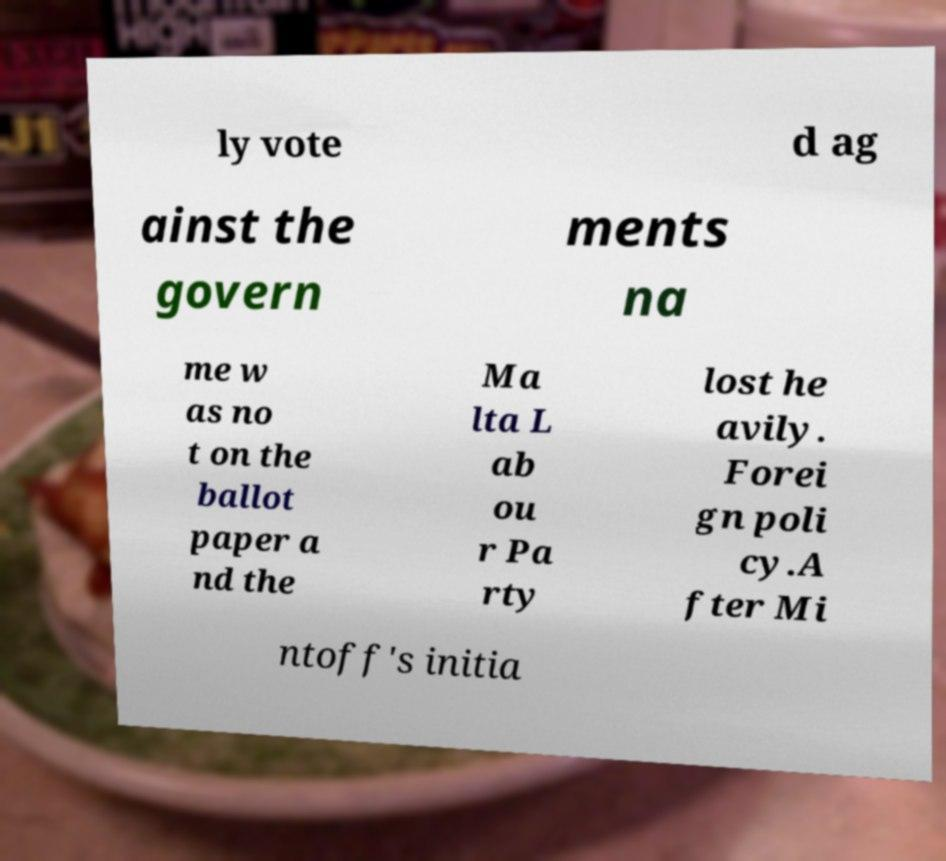Could you extract and type out the text from this image? ly vote d ag ainst the govern ments na me w as no t on the ballot paper a nd the Ma lta L ab ou r Pa rty lost he avily. Forei gn poli cy.A fter Mi ntoff's initia 